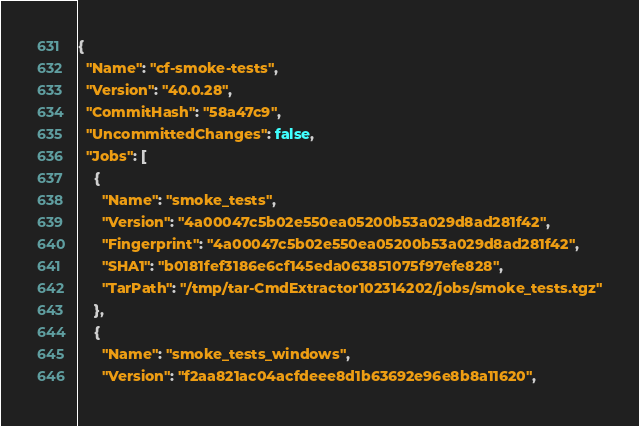<code> <loc_0><loc_0><loc_500><loc_500><_YAML_>{
  "Name": "cf-smoke-tests",
  "Version": "40.0.28",
  "CommitHash": "58a47c9",
  "UncommittedChanges": false,
  "Jobs": [
    {
      "Name": "smoke_tests",
      "Version": "4a00047c5b02e550ea05200b53a029d8ad281f42",
      "Fingerprint": "4a00047c5b02e550ea05200b53a029d8ad281f42",
      "SHA1": "b0181fef3186e6cf145eda063851075f97efe828",
      "TarPath": "/tmp/tar-CmdExtractor102314202/jobs/smoke_tests.tgz"
    },
    {
      "Name": "smoke_tests_windows",
      "Version": "f2aa821ac04acfdeee8d1b63692e96e8b8a11620",</code> 